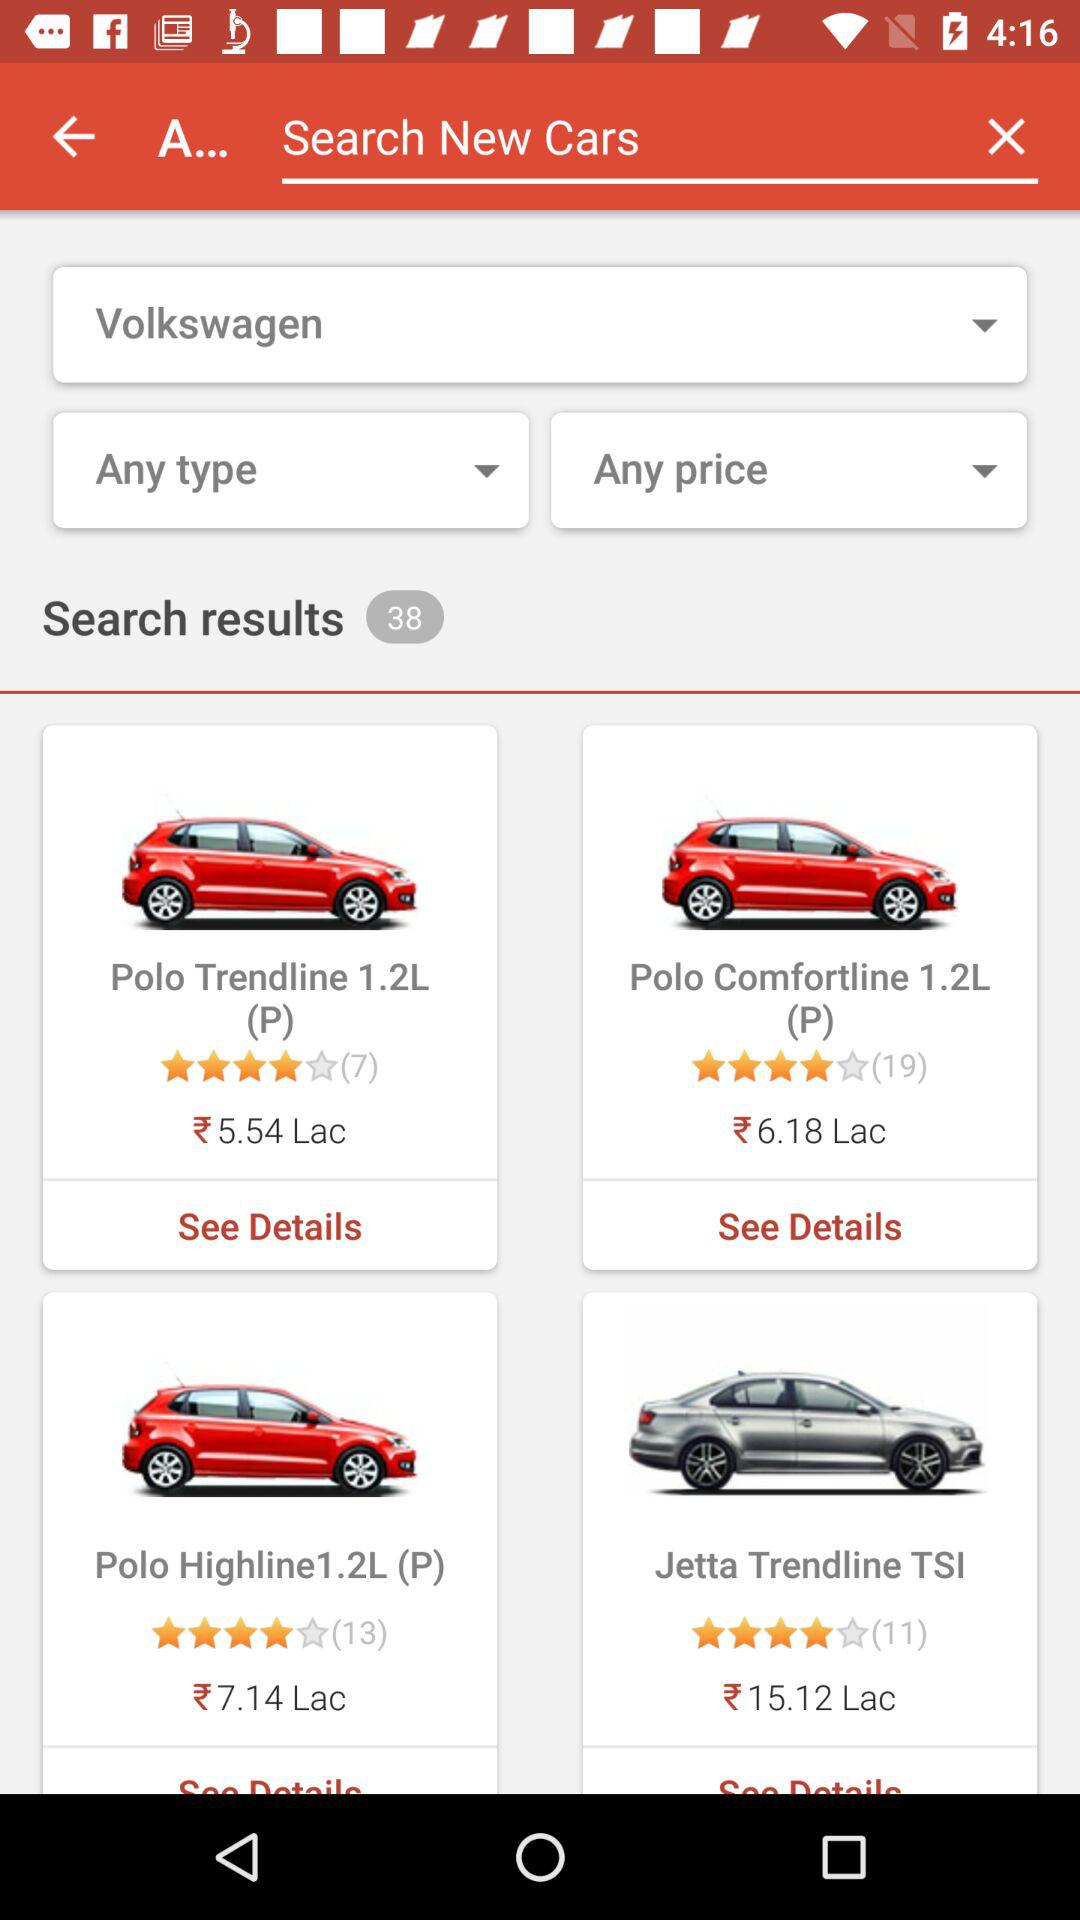What is the price of "Jetta Trendline TSI"? The price is ₹15.12 lac. 